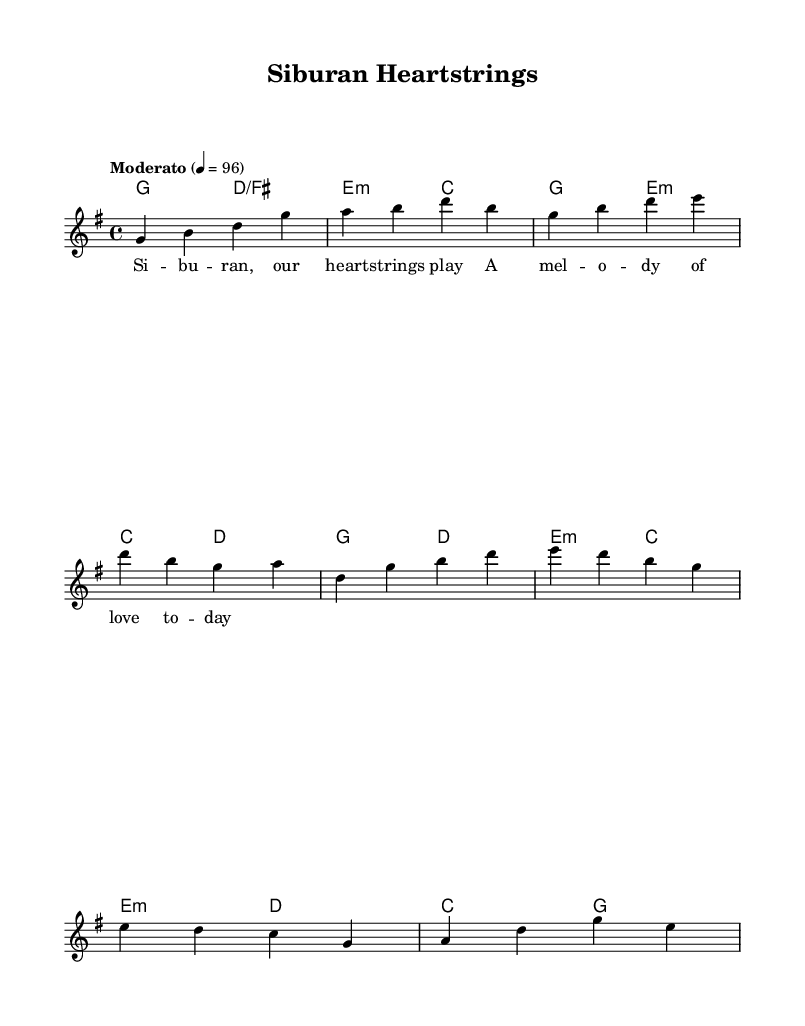What is the key signature of this music? The key signature is G major, which contains one sharp (F#). This can be determined from the beginning of the sheet music where the key signature is indicated.
Answer: G major What is the time signature of this music? The time signature is 4/4, meaning there are four beats in each measure and the quarter note gets one beat. This is visible at the start of the score where the time signature is notated.
Answer: 4/4 What is the tempo of this music? The tempo is Moderato, set at 96 beats per minute. This is indicated in the tempo marking at the beginning of the score.
Answer: Moderato, 96 How many measures are there in the melody section? There are eight measures in the melody section. This can be counted by observing the visual grouping of the measures on the staff.
Answer: Eight What instrument is primarily indicated for the melody? The primary instrument for the melody is the lead voice, as indicated by the label “lead” in the staff designation.
Answer: Lead In which part is the bridge section located? The bridge section is located after the chorus, as indicated by the flow of the music structure and the labeling of sections. It typically contrasts with the preceding material.
Answer: Bridge What is the overall theme reflected in the lyrics provided? The overall theme reflected in the lyrics is love and connection to Siburan, highlighting emotions and local pride. This can be inferred from the lyric text focusing on "heartstrings" and "melody of love."
Answer: Love and connection 